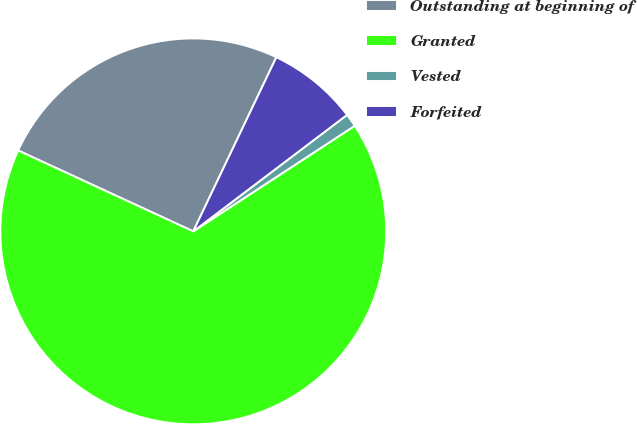Convert chart. <chart><loc_0><loc_0><loc_500><loc_500><pie_chart><fcel>Outstanding at beginning of<fcel>Granted<fcel>Vested<fcel>Forfeited<nl><fcel>25.2%<fcel>66.11%<fcel>1.1%<fcel>7.6%<nl></chart> 